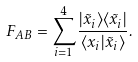<formula> <loc_0><loc_0><loc_500><loc_500>F _ { A B } = \sum _ { i = 1 } ^ { 4 } \frac { | \tilde { x } _ { i } \rangle \langle \tilde { x } _ { i } | } { \langle x _ { i } | \tilde { x } _ { i } \rangle } .</formula> 